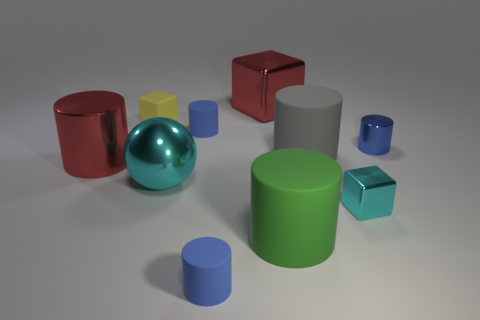Subtract all blue cylinders. How many were subtracted if there are1blue cylinders left? 2 Subtract all green blocks. How many blue cylinders are left? 3 Subtract 3 cylinders. How many cylinders are left? 3 Subtract all red cylinders. How many cylinders are left? 5 Subtract all large gray cylinders. How many cylinders are left? 5 Subtract all gray cylinders. Subtract all purple cubes. How many cylinders are left? 5 Subtract all balls. How many objects are left? 9 Add 8 large gray rubber cylinders. How many large gray rubber cylinders exist? 9 Subtract 0 yellow spheres. How many objects are left? 10 Subtract all purple metallic cylinders. Subtract all small yellow rubber cubes. How many objects are left? 9 